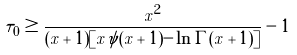Convert formula to latex. <formula><loc_0><loc_0><loc_500><loc_500>\tau _ { 0 } \geq \frac { x ^ { 2 } } { ( x + 1 ) [ x \psi ( x + 1 ) - \ln \Gamma ( x + 1 ) ] } - 1</formula> 